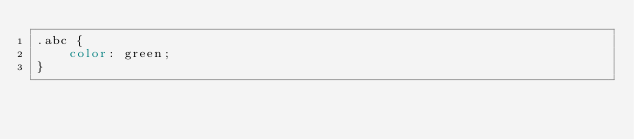Convert code to text. <code><loc_0><loc_0><loc_500><loc_500><_CSS_>.abc {
    color: green;
}</code> 